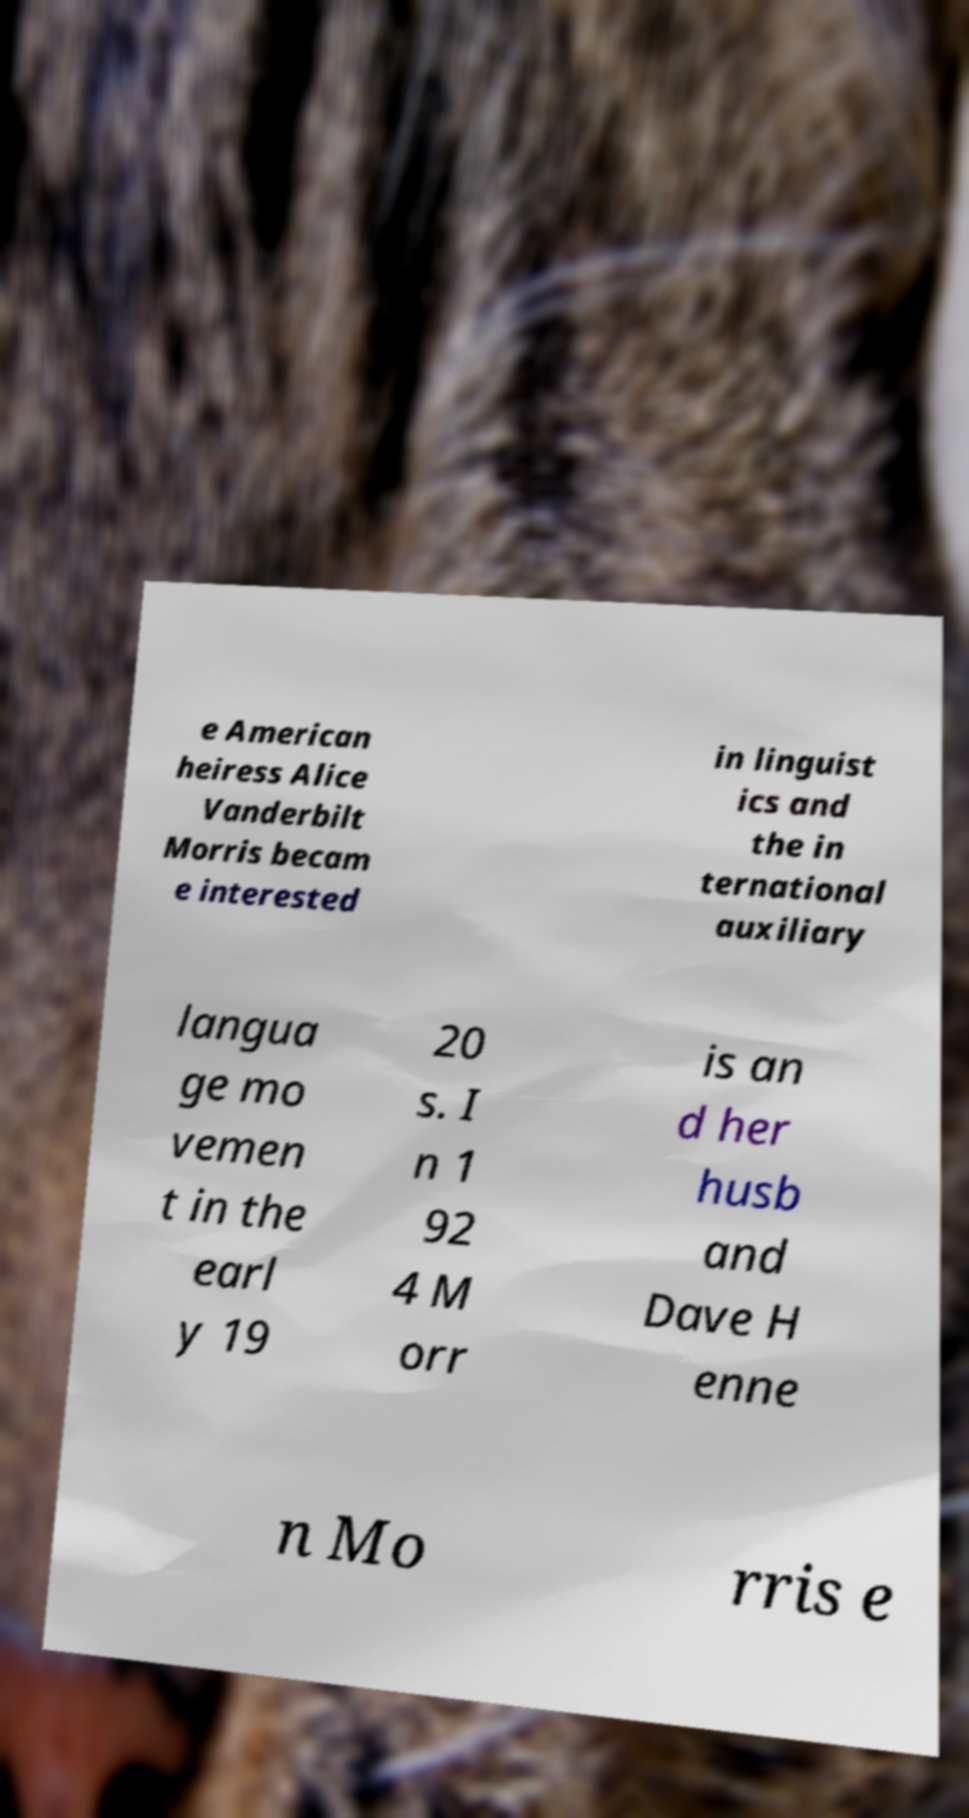I need the written content from this picture converted into text. Can you do that? e American heiress Alice Vanderbilt Morris becam e interested in linguist ics and the in ternational auxiliary langua ge mo vemen t in the earl y 19 20 s. I n 1 92 4 M orr is an d her husb and Dave H enne n Mo rris e 